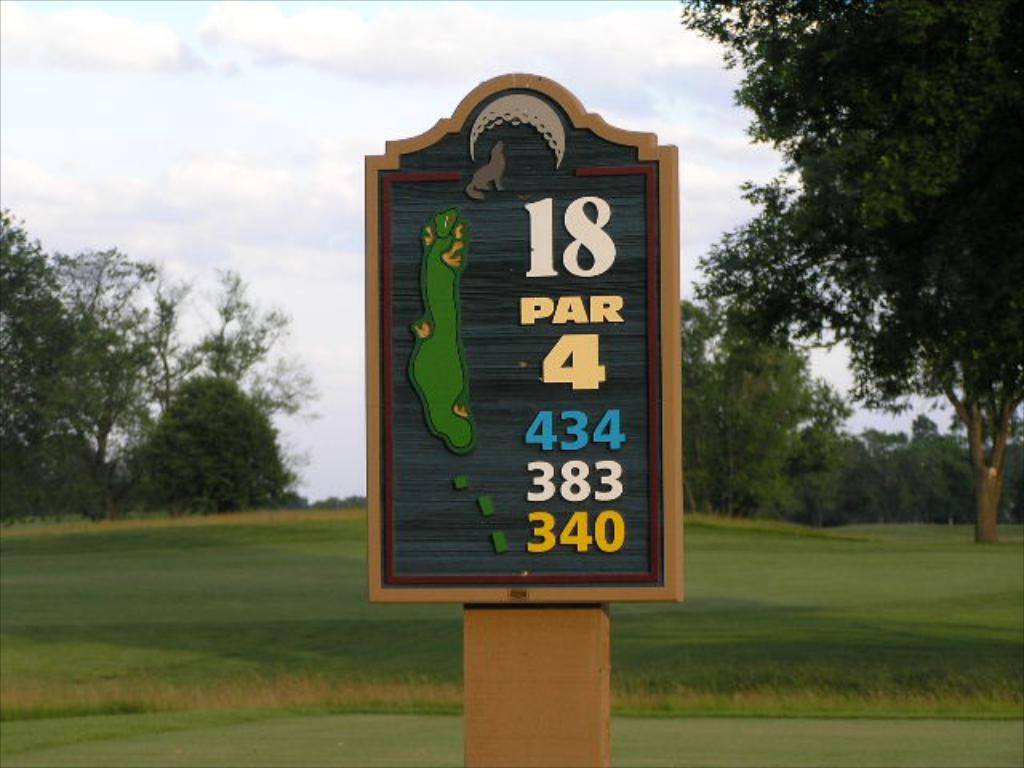<image>
Write a terse but informative summary of the picture. A sign out in the open field that reads 18 PAR 4 434 383 340 with trees in the background. 